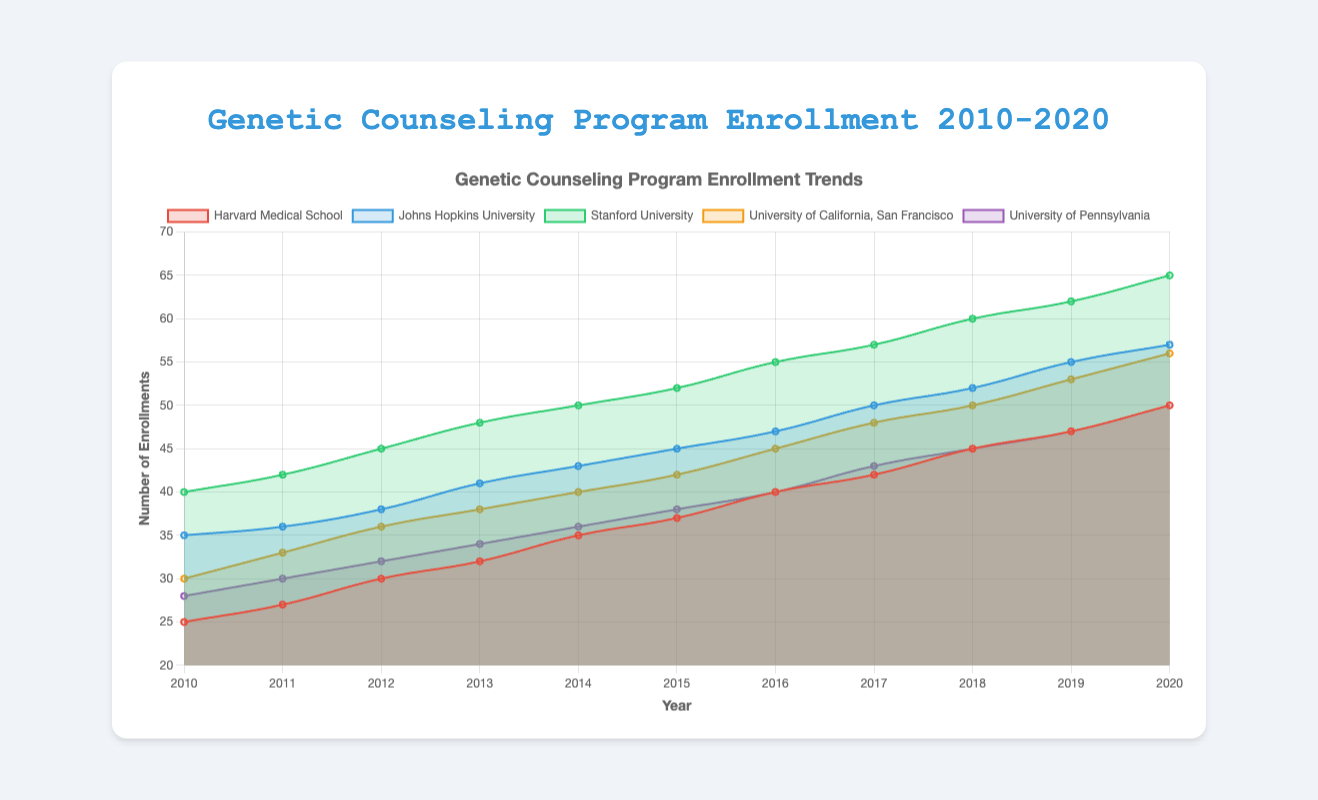Which university had the highest enrollment in 2020? By observing the figure and finding the data point for the year 2020, Stanford University has the highest enrollment of 65.
Answer: Stanford University How many students enrolled in Harvard Medical School in total from 2017 to 2020? Sum the enrollments for Harvard Medical School from 2017 to 2020: 42 + 45 + 47 + 50 = 184.
Answer: 184 From which year did Johns Hopkins University see a consistent rise in enrollments each year, starting from a particular year until 2020? By observing the trend line for Johns Hopkins University, a consistent rise in enrollments each year starts from 2010 and continues until 2020 without any drop.
Answer: 2010 Which university experienced the largest increase in enrollment between 2015 and 2020? Calculate the difference in enrollments between 2015 and 2020 for each university: Harvard (50-37=13), Johns Hopkins (57-45=12), Stanford (65-52=13), UCSF (56-42=14), Penn (50-38=12). UCSF has the largest increase of 14.
Answer: University of California, San Francisco What was the enrollment trend for the University of Pennsylvania from 2010 to 2014? By observing the trend line for the University of Pennsylvania from 2010 to 2014, we can see a steady but slow increase in enrollments.
Answer: Steady and slow increase Compare the enrollments in 2012 for Stanford University and Johns Hopkins University. Which one is higher and by how much? Find the enrollments for 2012: Stanford University has 45 and Johns Hopkins University has 38, the difference is 45 - 38 = 7. Stanford University is higher by 7.
Answer: Stanford University by 7 Identify the year with the biggest increase in enrollment for any single university. Compare the year-to-year enrollment increases for all universities and identify the largest increase. For Harvard: 2 (2010-2011), 3 (2011-2012), 2 (2012-2013), 3 (2013-2014), 2 (2014-2015), 3 (2015-2016), 2 (2016-2017), 3 (2017-2018), 2 (2018-2019), 3 (2019-2020). The biggest single year increase is 3 for multiple years (Harvard from 2012 to 2013, 2014 to 2015). Apply this comparison to all universities; Stanford from 2012 to 2013 shows the largest single year increase by 3.
Answer: 2012 - 2013 Stanford University 